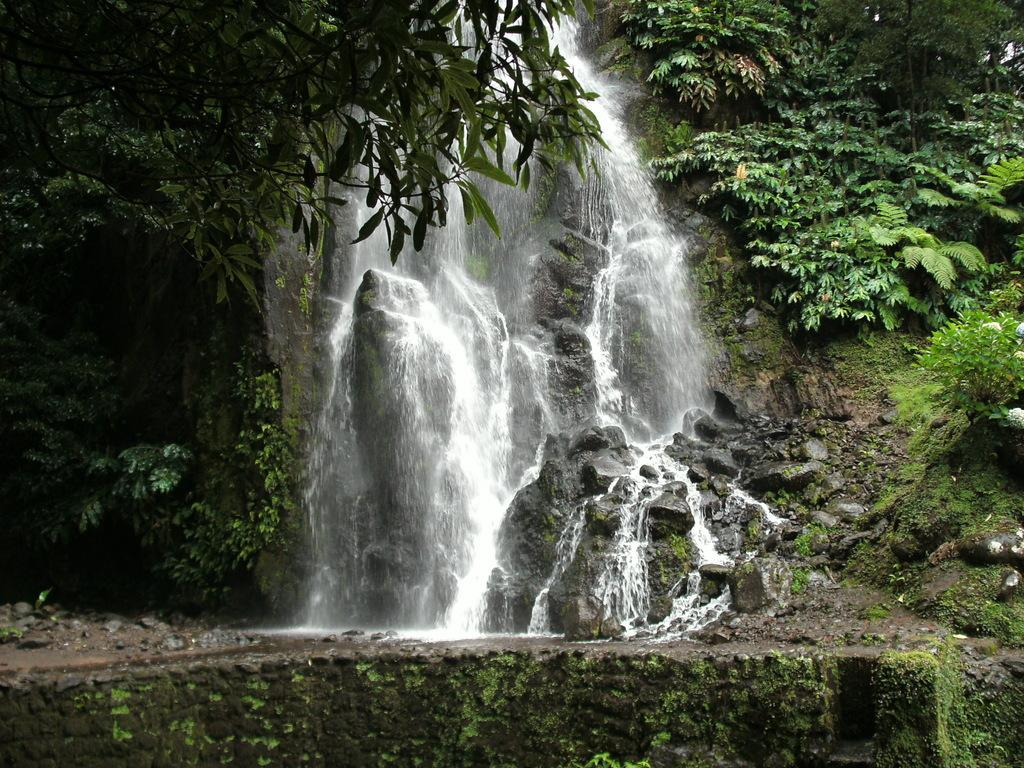What is the main feature in the center of the image? There is a waterfall in the center of the image. What can be seen in the background of the image? There are trees in the background of the image. What type of loaf is being used to measure the weather in the image? There is no loaf present in the image, and the weather is not being measured. 